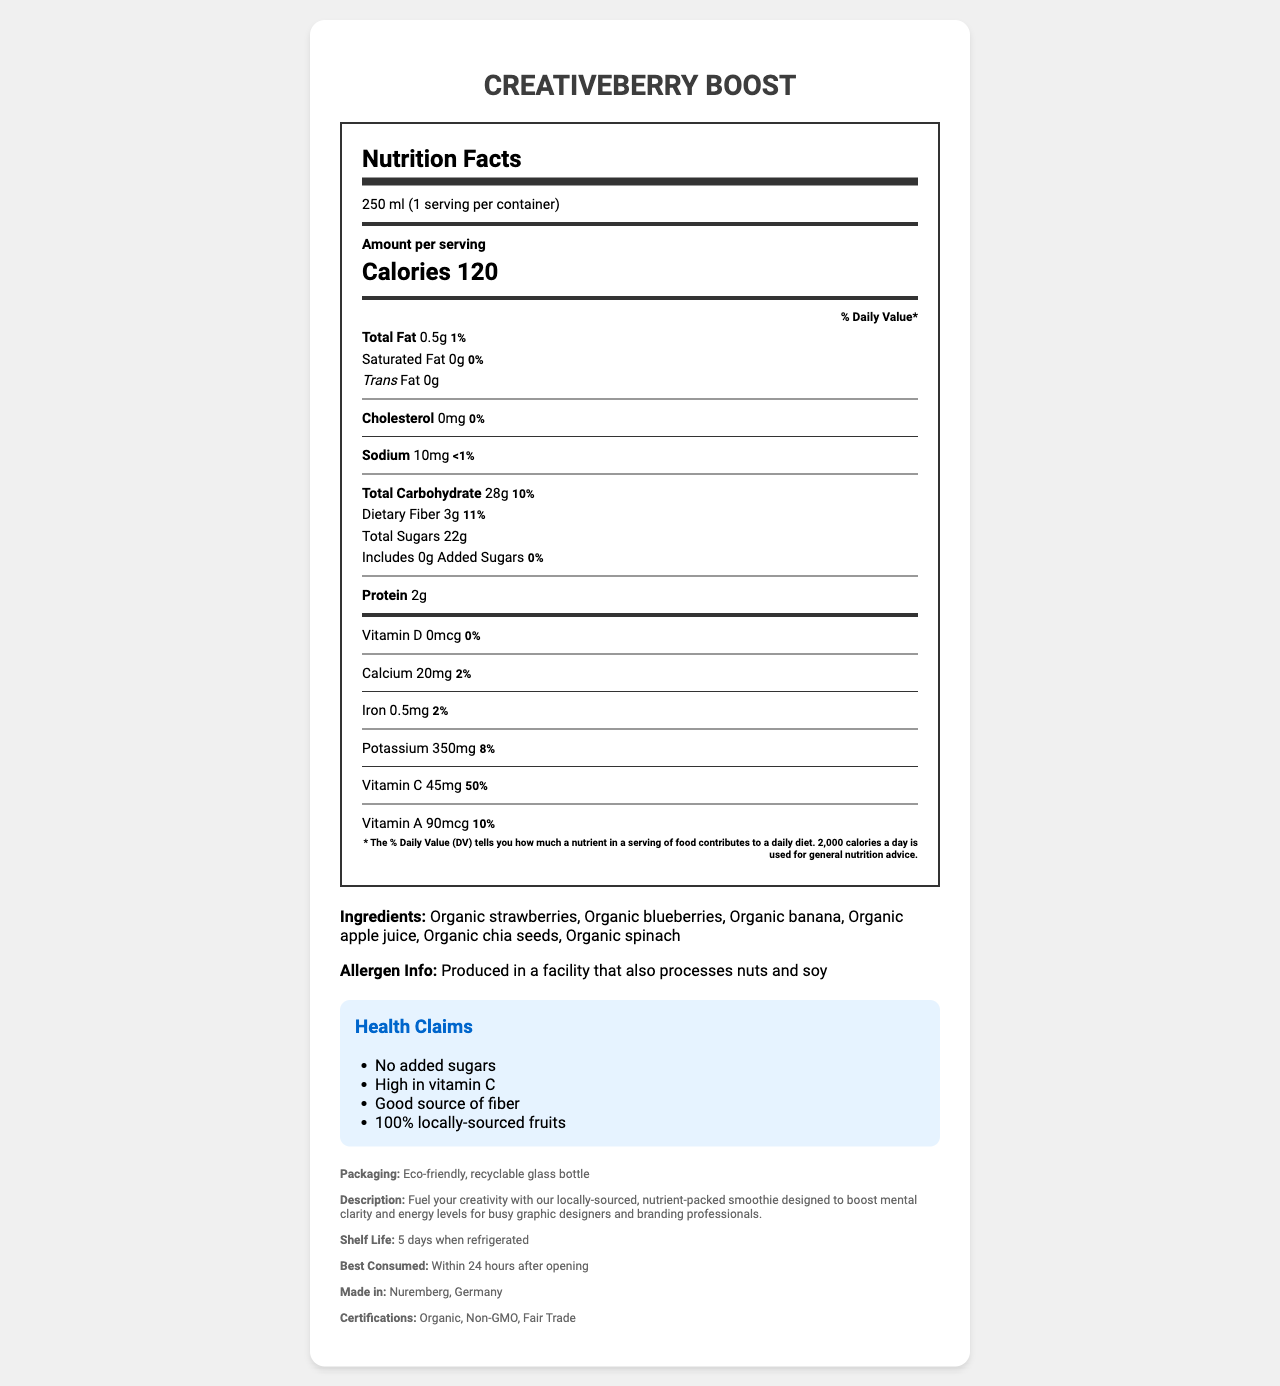What is the serving size of the CreativeBerry Boost smoothie? The serving size information is found at the top of the Nutrition Facts section where it states "250 ml".
Answer: 250 ml How many calories are in one serving of CreativeBerry Boost? The calorie content is prominently displayed in the Nutrition Facts section, specifically mentioning "Calories 120".
Answer: 120 Name three key ingredients in CreativeBerry Boost. The ingredients list within the document mentions these key ingredients.
Answer: Organic strawberries, Organic blueberries, Organic banana Which vitamin has the highest daily value percentage in CreativeBerry Boost? The Nutrition Facts section shows that Vitamin C has a daily value of 50%, which is the highest among the listed vitamins and minerals.
Answer: Vitamin C Is there any added sugar in the CreativeBerry Boost smoothie? The Nutrition Facts section clearly states "Includes 0g Added Sugars".
Answer: No What are the health claims made for CreativeBerry Boost smoothie? A. Contains added sugars B. High in protein C. High in vitamin C D. Locally-sourced fruits The document lists "no added sugars, high in vitamin C, and 100% locally-sourced fruits" under health claims.
Answer: C, D How much protein is in one serving of CreativeBerry Boost? A. 1g B. 2g C. 3g D. 4g The Nutrition Facts section mentions "Protein 2g".
Answer: B Is the product certified organic? The certifications section under additional info lists "Organic" as one of its certifications.
Answer: Yes What should you be cautious of regarding allergens with this product? A. Contains nuts B. Produced in a facility that processes nuts and soy C. Contains dairy D. Contains wheat The ingredient and allergen information states "Produced in a facility that also processes nuts and soy".
Answer: B Where is the CreativeBerry Boost smoothie made? The additional info section clearly states the product is made in Nuremberg, Germany.
Answer: Nuremberg, Germany How long can you store the CreativeBerry Boost smoothie when refrigerated? The additional info section mentions a shelf life of "5 days when refrigerated".
Answer: 5 days What is the packaging type for CreativeBerry Boost? The additional info section specifically notes "Eco-friendly, recyclable glass bottle" as the packaging type.
Answer: Eco-friendly, recyclable glass bottle Which ingredient provides fiber in the CreativeBerry Boost smoothie? Chia seeds are known for their high fiber content, and they are listed among the ingredients.
Answer: Organic chia seeds How much dietary fiber does one serving of CreativeBerry Boost provide? The Nutrition Facts section lists "Dietary Fiber 3g".
Answer: 3g Does CreativeBerry Boost have any trans fats? The Nutrition Facts section indicates "Trans Fat 0g".
Answer: No What is the total carbohydrate content in the CreativeBerry Boost? The total carbohydrate content is listed in the Nutrition Facts section as "Total Carbohydrate 28g".
Answer: 28g Summarize the main idea of the document. The document covers various aspects including serving size, calorie content, ingredients, nutritional values, health claims, allergen information, packaging, product description, shelf life, and certifications.
Answer: CreativeBerry Boost is a nutrient-rich, locally-sourced fruit smoothie designed for creative professionals, offering high vitamin C, no added sugars, and eco-friendly packaging, while also being made with organic and fair-trade certified ingredients. Is the content of this smoothie consistent with vegan dietary preferences? The document does not explicitly state whether the product is vegan, though the listed ingredients suggest it could be. Confirmation would need to be verified from additional sources.
Answer: Cannot be determined 